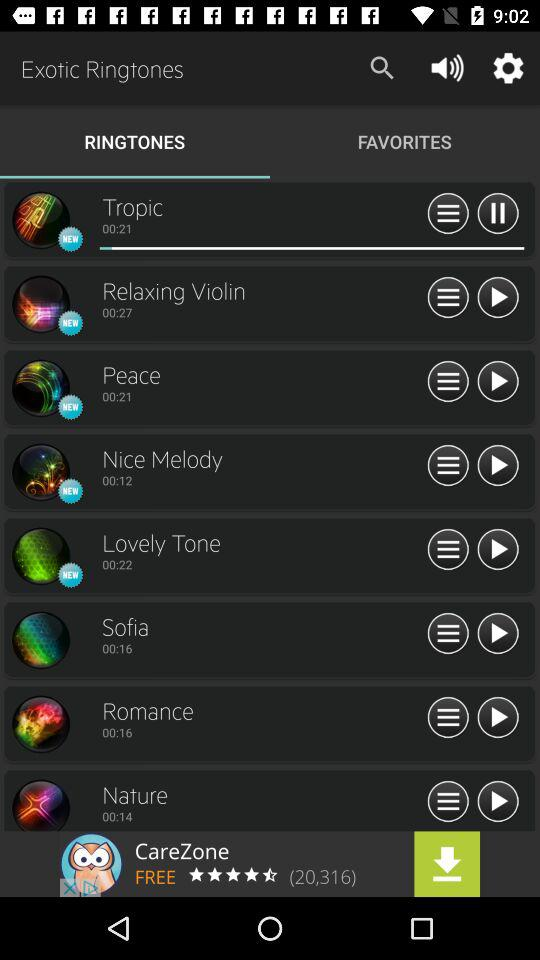What is the duration of the peace ringtone? The duration of the peace ringtone is 00:21. 